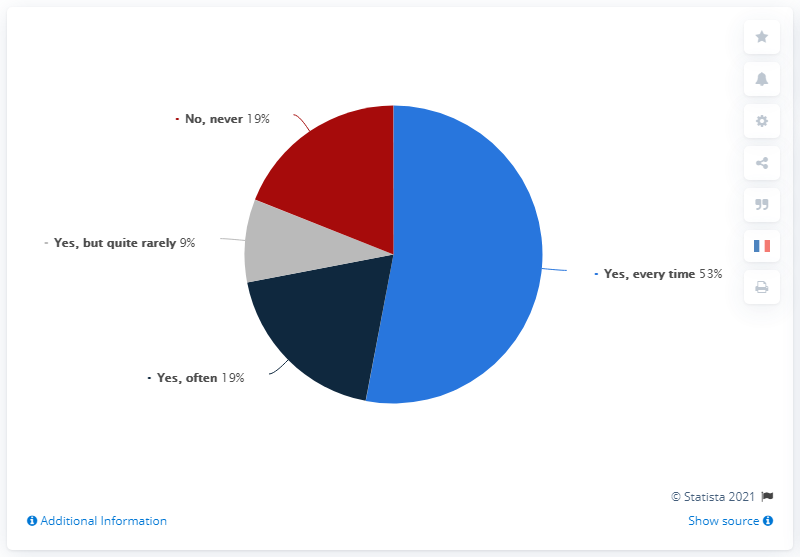Draw attention to some important aspects in this diagram. The ratio of 'no, never' to 'yes, often' is 1 to 1. It is the opinion of 9% of people, but it is not a common one. 